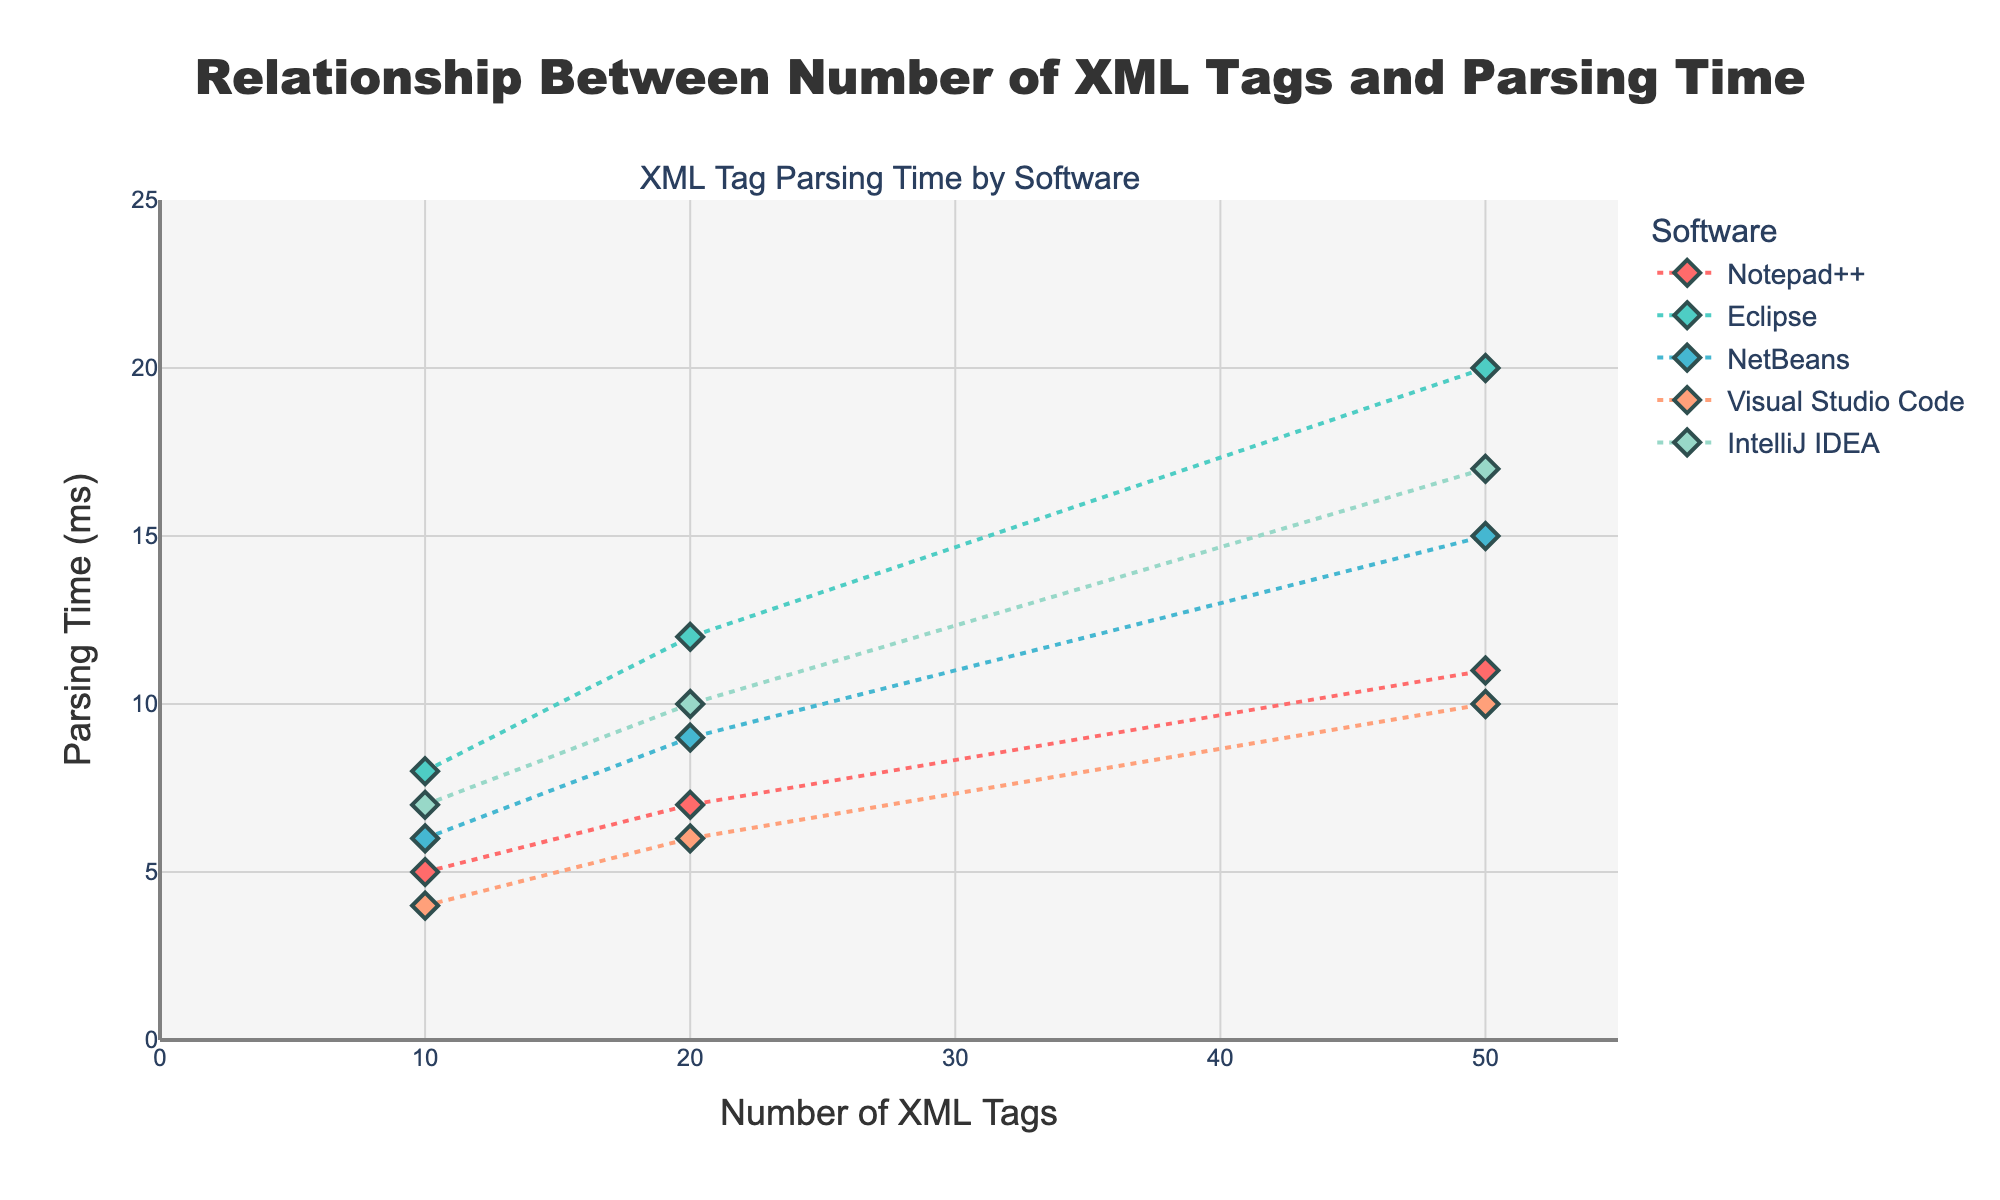How many softwares are represented in the figure? The figure includes different colored markers specific to each software. By counting the distinct colors and legend entries, we can identify the number of different softwares.
Answer: 5 Which software has the shortest parsing time for 50 XML tags? By looking at the y-axis values for each marker at the x-value of 50 (number of tags), it is evident that Visual Studio Code has the shortest parsing time.
Answer: Visual Studio Code What's the difference in parsing time between Eclipse and NetBeans for 20 XML tags? Locate the data points for Eclipse and NetBeans at the x-value of 20. Eclipse shows a parsing time of 12 ms, and NetBeans shows 9 ms. The difference is calculated as 12 - 9.
Answer: 3 ms What trend do you observe in parsing times as the number of XML tags increases for Notepad++? By examining the line connecting the markers for Notepad++ from 10 to 50 tags, we see a steady increase in parsing times.
Answer: Steady increase On average, how much time does IntelliJ IDEA take to parse 10, 20, and 50 XML tags? Observe the parsing times for IntelliJ IDEA at 10 (7 ms), 20 (10 ms), and 50 (17 ms). Calculate the average using (7 + 10 + 17) / 3.
Answer: 11.33 ms Which software shows the most significant increase in parsing time from 10 to 50 tags? Compare the differences in parsing times at 10 and 50 tags for each software. Eclipse increases from 8 ms to 20 ms, which is the largest difference of 12 ms.
Answer: Eclipse Is there any software that has a linear relationship between the number of XML tags and parsing time? By looking at the lines connecting the markers, Visual Studio Code shows a relatively linear increase across all numbers of tags.
Answer: Visual Studio Code Which software has the most consistent parsing times across different numbers of XML tags? Consistency can be judged by the least variation in y-values. Visual Studio Code appears to have the most consistent performance.
Answer: Visual Studio Code What is the parsing time for NetBeans with 10 XML tags? Locate the NetBeans marker at the x-value of 10 tags, which corresponds to the y-value.
Answer: 6 ms Does any software have a non-linear increase in parsing times? Observing the curves for each software, Eclipse shows a non-linear increase as the parsing time jumps significantly from 20 ms for 20 tags to 50 ms.
Answer: Eclipse 